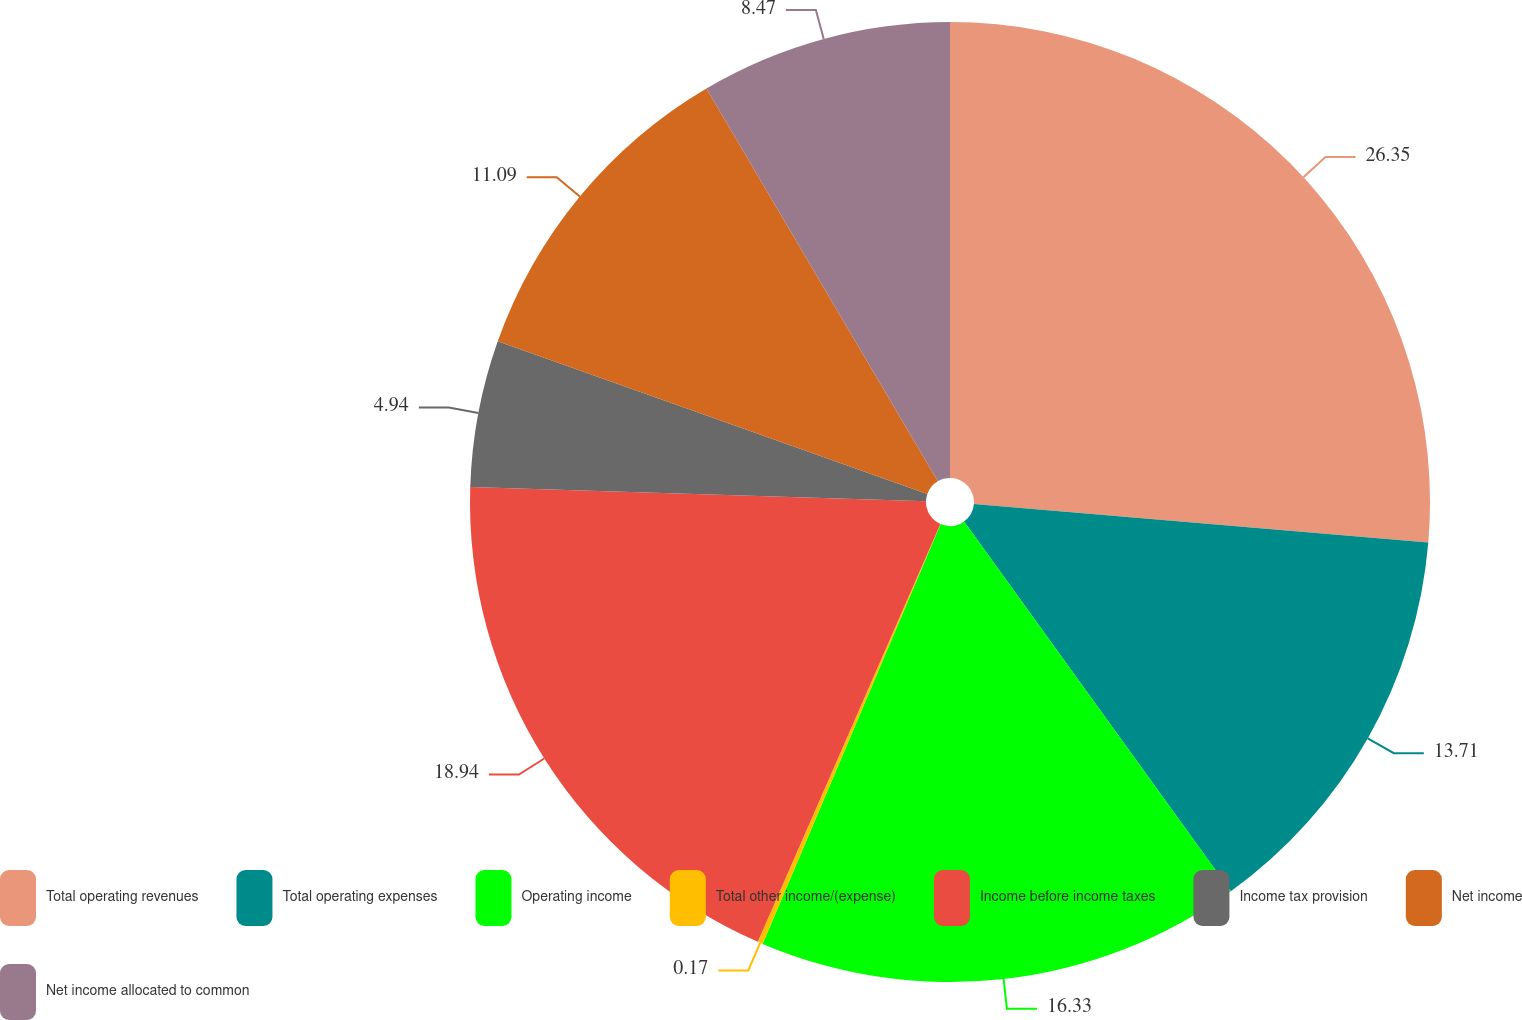<chart> <loc_0><loc_0><loc_500><loc_500><pie_chart><fcel>Total operating revenues<fcel>Total operating expenses<fcel>Operating income<fcel>Total other income/(expense)<fcel>Income before income taxes<fcel>Income tax provision<fcel>Net income<fcel>Net income allocated to common<nl><fcel>26.34%<fcel>13.71%<fcel>16.33%<fcel>0.17%<fcel>18.94%<fcel>4.94%<fcel>11.09%<fcel>8.47%<nl></chart> 